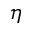<formula> <loc_0><loc_0><loc_500><loc_500>\eta</formula> 